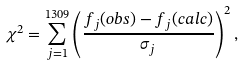<formula> <loc_0><loc_0><loc_500><loc_500>\chi ^ { 2 } = \sum _ { j = 1 } ^ { 1 3 0 9 } \left ( \frac { f _ { j } ( { o b s } ) - f _ { j } ( { c a l c } ) } { \sigma _ { j } } \right ) ^ { 2 } ,</formula> 